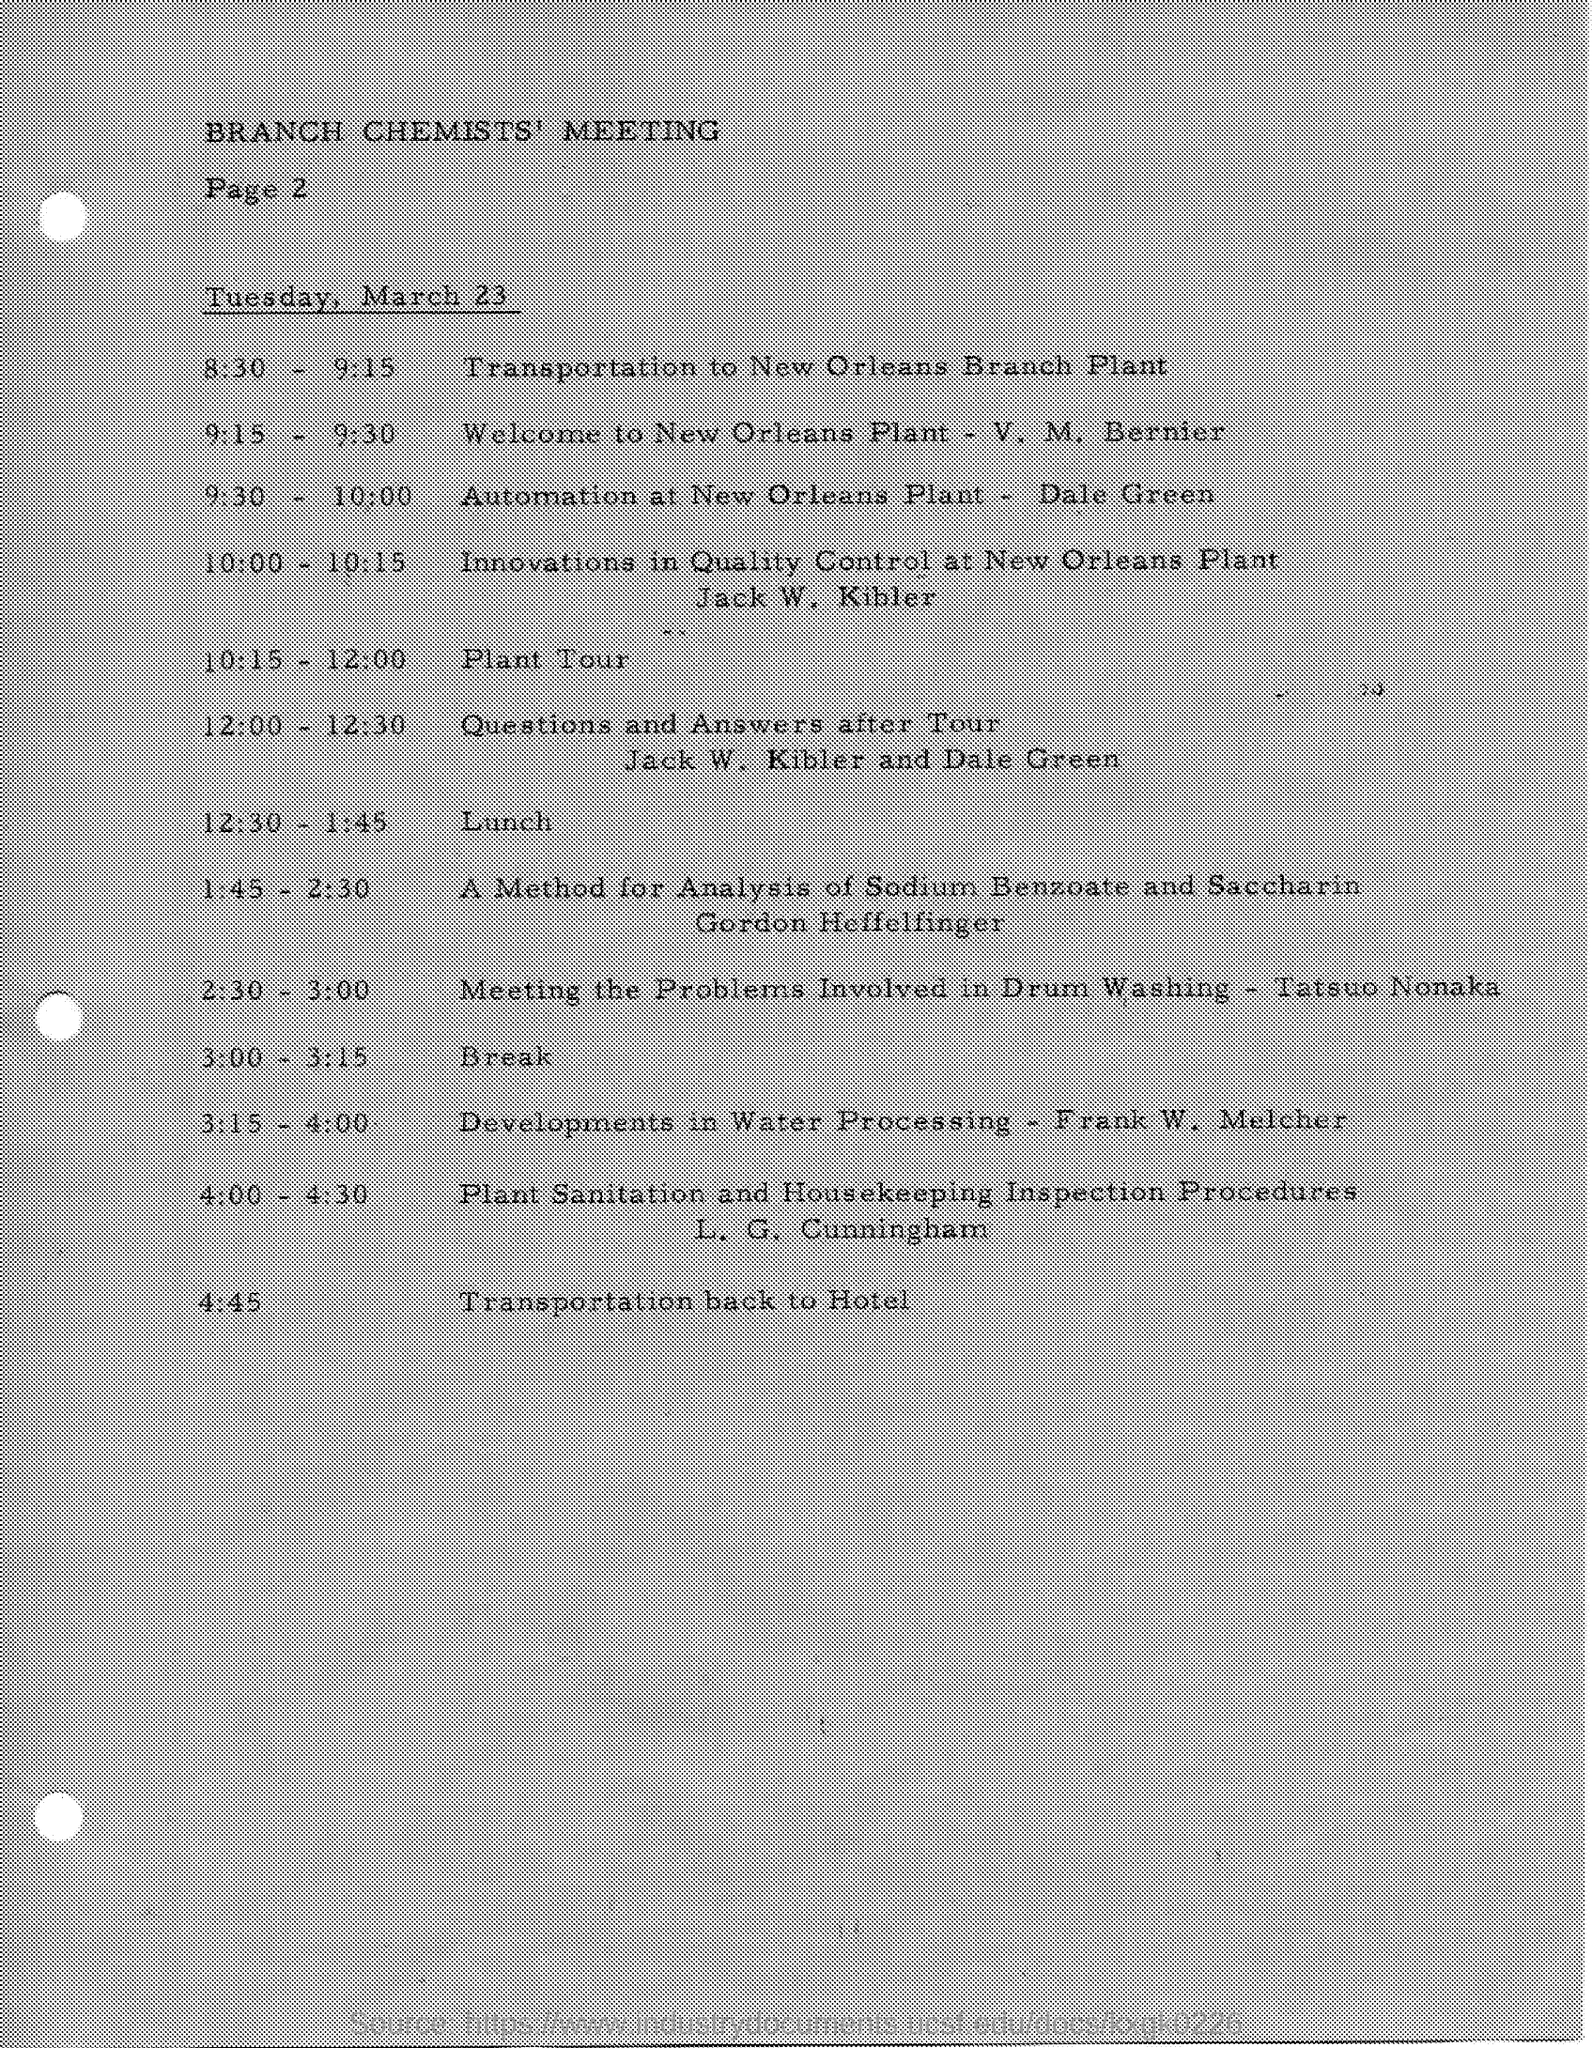What is lunch time?
Give a very brief answer. 12.30 - 1.45. What is date mentioned
Provide a succinct answer. Tuesday, March 23. What meeting is mentioned?
Your answer should be very brief. Branch chemists' meeting. 